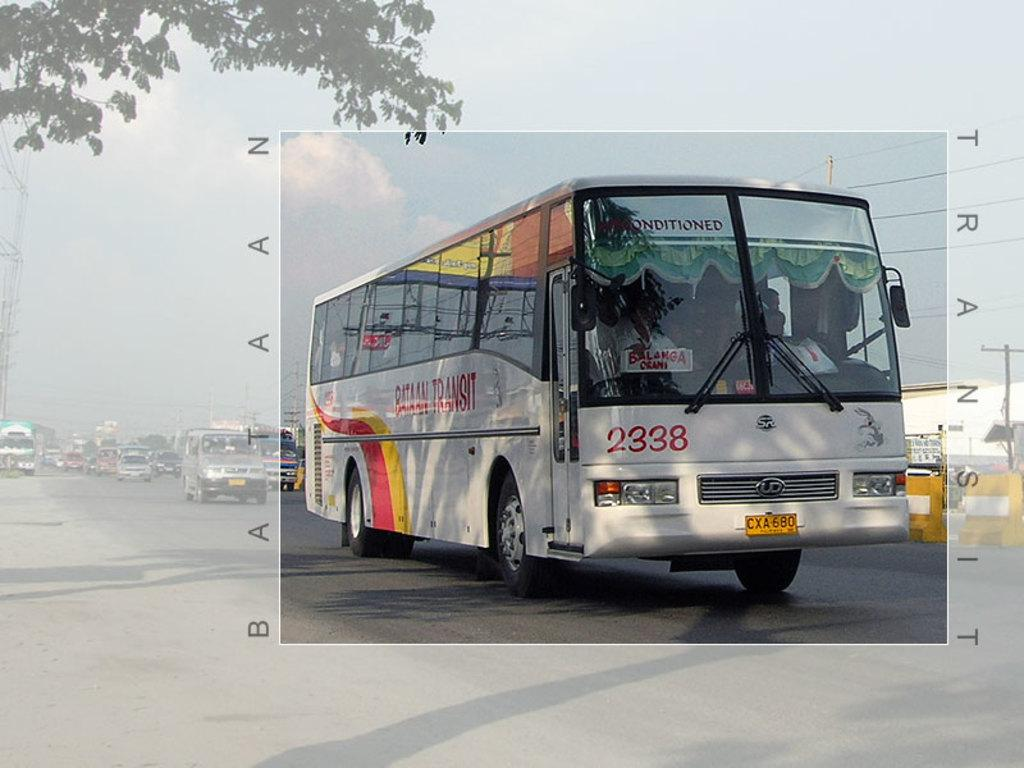What can be seen on the road in the image? There are vehicles on the road in the image. What is the surface that the vehicles are traveling on? The road is visible in the image. What is connected to the electric pole in the image? Electric wires are present in the image. What type of structure can be seen in the image? There is a building in the image. What is the condition of the sky in the image? The sky is cloudy in the image. Can you tell me how many feathers are floating in the sky in the image? There are no feathers present in the image; the sky is cloudy. What type of idea is being discussed by the vehicles in the image? There is no indication of any ideas being discussed by the vehicles in the image, as they are simply traveling on the road. 